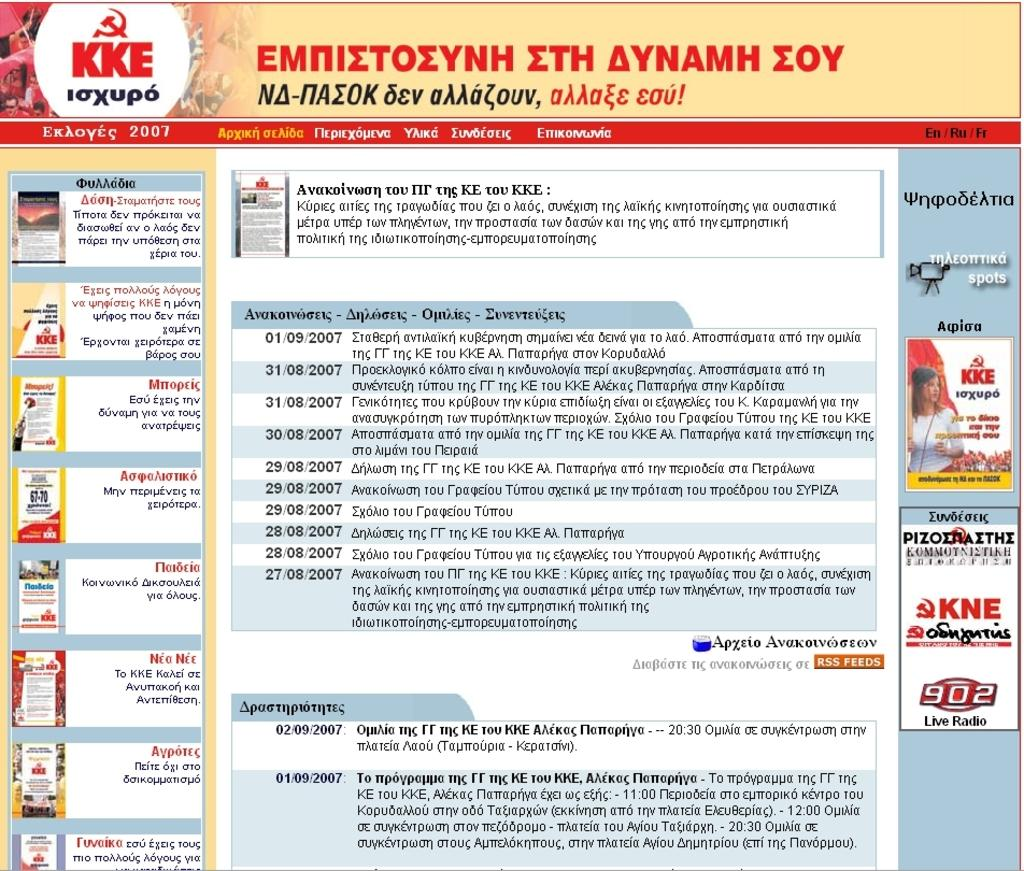What is the main object in the image? The image contains a poster. What can be found on the poster? There is text on the poster. Is there any image on the poster? Yes, there is a woman's image on the right side of the poster. What type of bell can be seen hanging from the woman's neck in the image? There is no bell present in the image; it only features a woman's image on the right side of the poster. What historical event is depicted in the image? The image does not depict any historical event; it only contains a poster with text and a woman's image. 